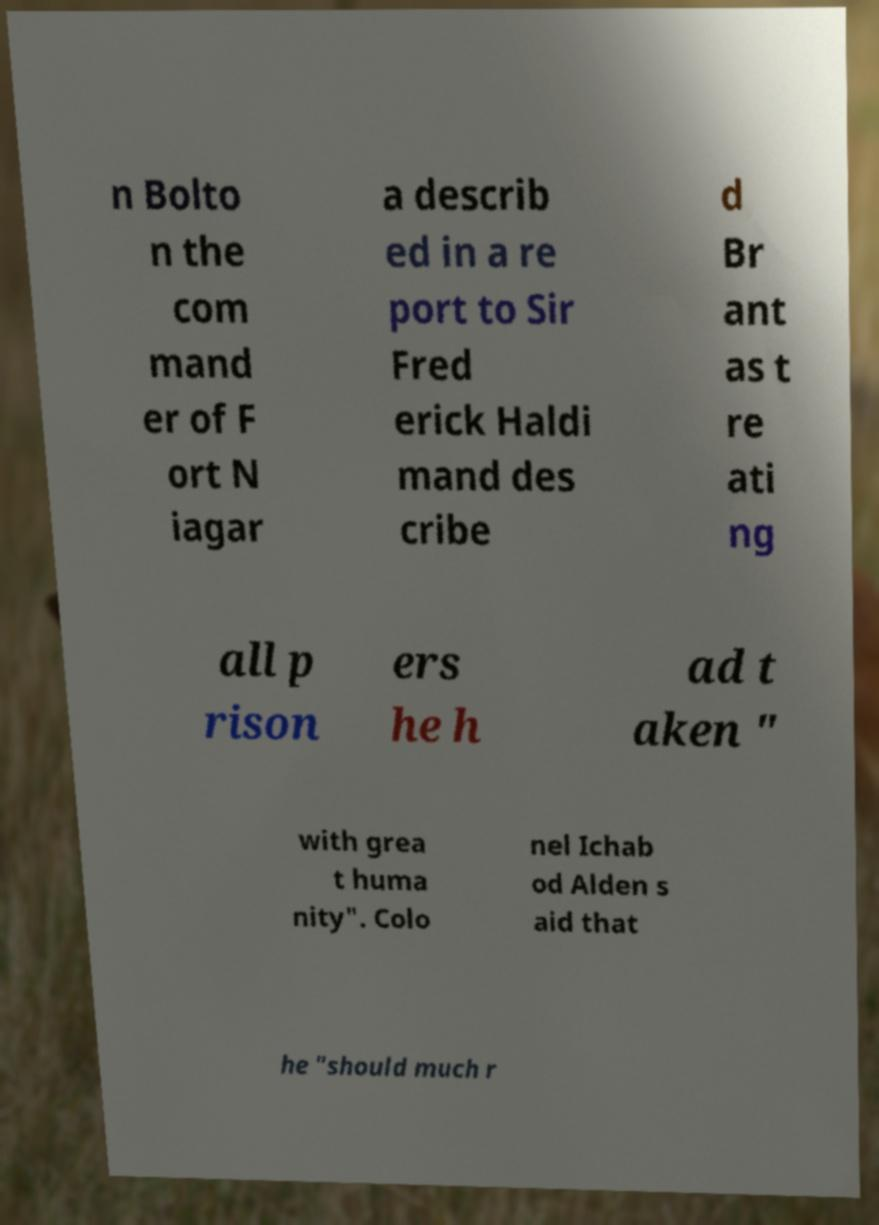There's text embedded in this image that I need extracted. Can you transcribe it verbatim? n Bolto n the com mand er of F ort N iagar a describ ed in a re port to Sir Fred erick Haldi mand des cribe d Br ant as t re ati ng all p rison ers he h ad t aken " with grea t huma nity". Colo nel Ichab od Alden s aid that he "should much r 